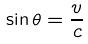Convert formula to latex. <formula><loc_0><loc_0><loc_500><loc_500>\sin \theta = \frac { v } { c }</formula> 